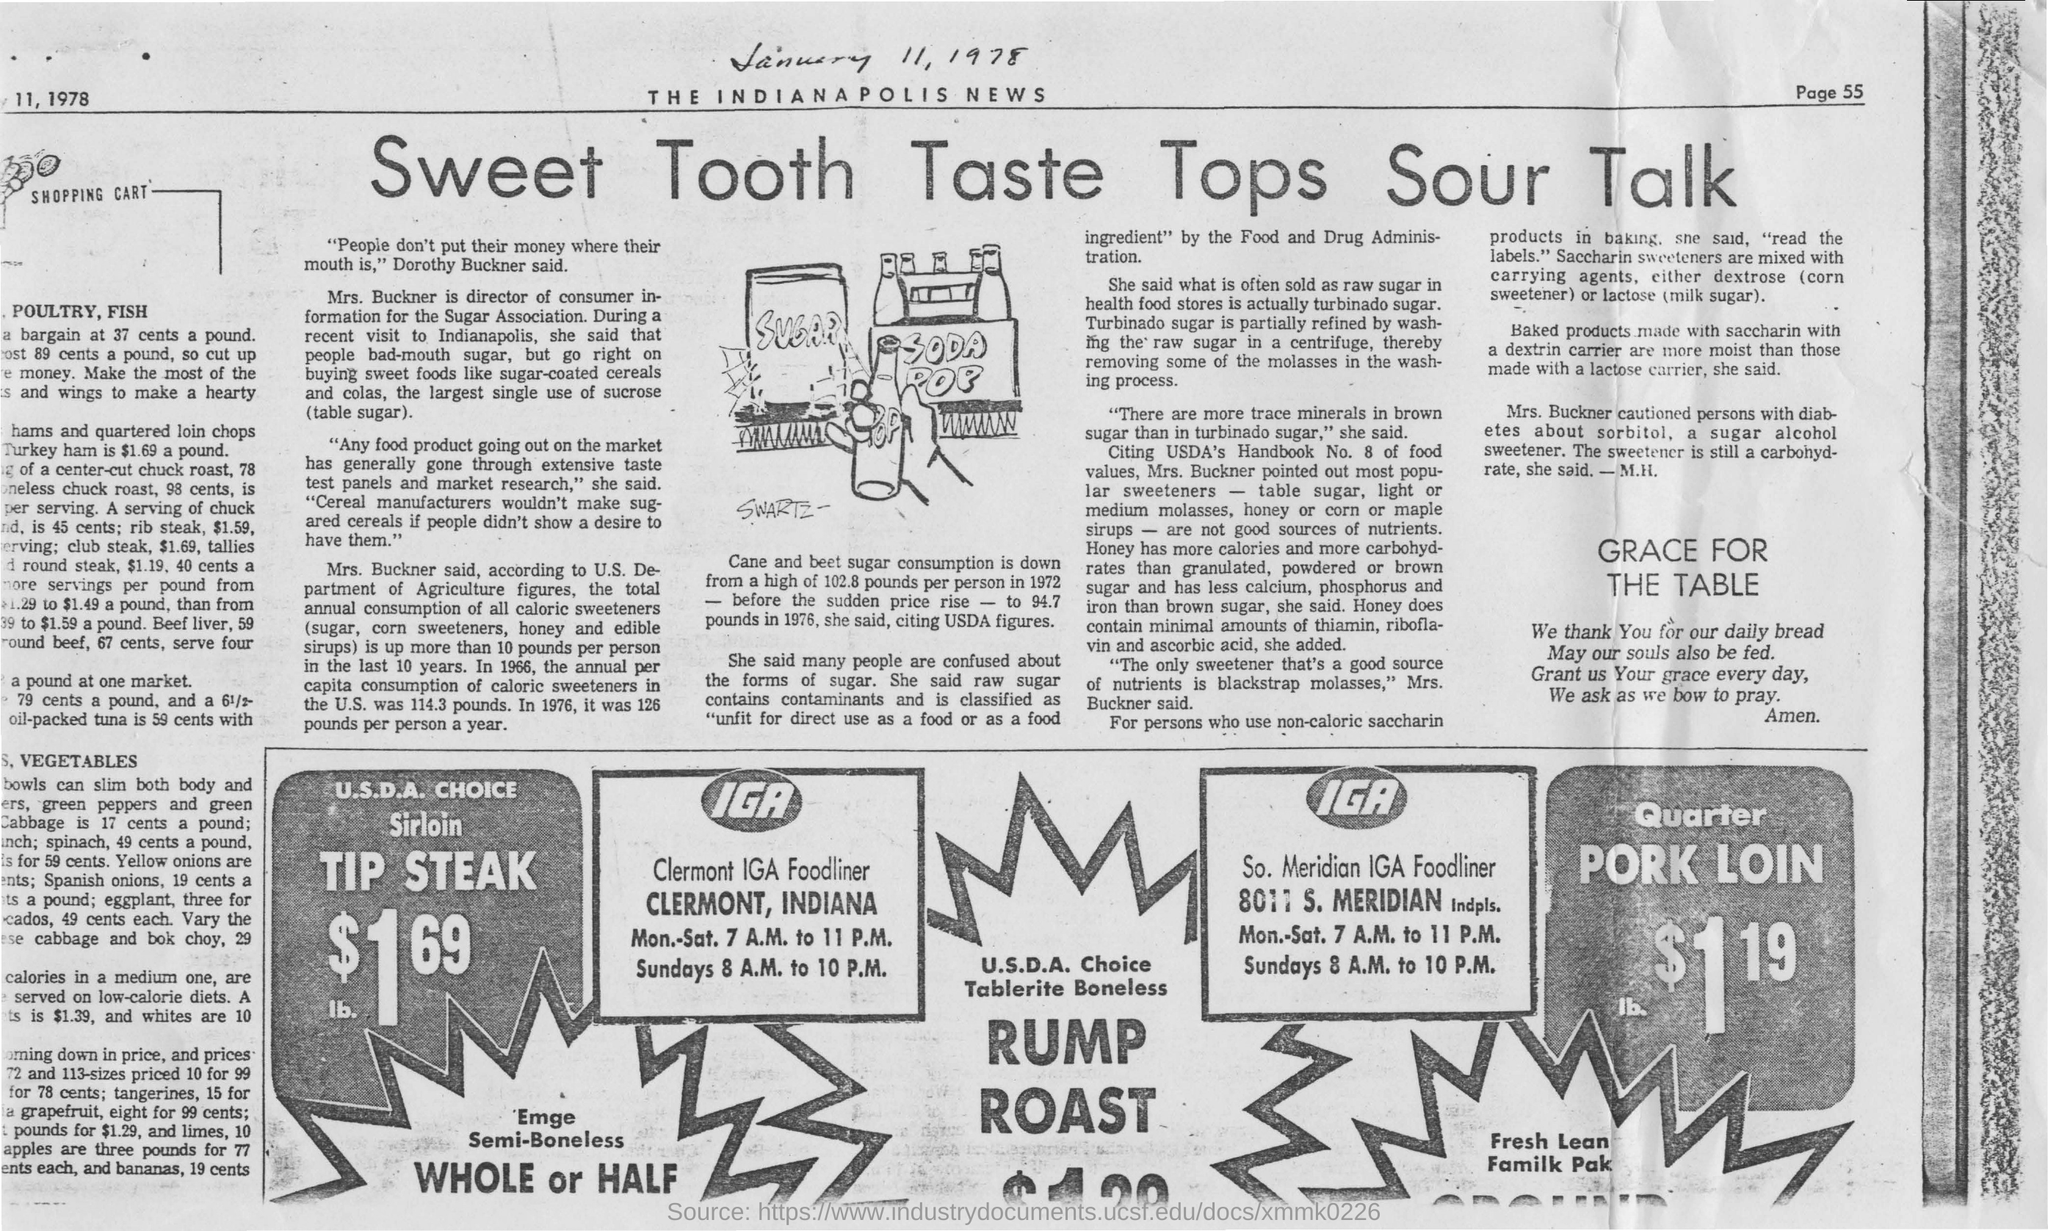What is the heading of the document?
Your answer should be compact. Sweet Tooth Taste Tops Sour Talk. What is the cost of TIP STEAK?
Provide a succinct answer. $1 69. What is the cost of PORK LOIN?
Your answer should be compact. $1.19. What is the timing for Clermont IGA foodliner on Sundays?
Your response must be concise. 8 A.M. to 10 P.M. 